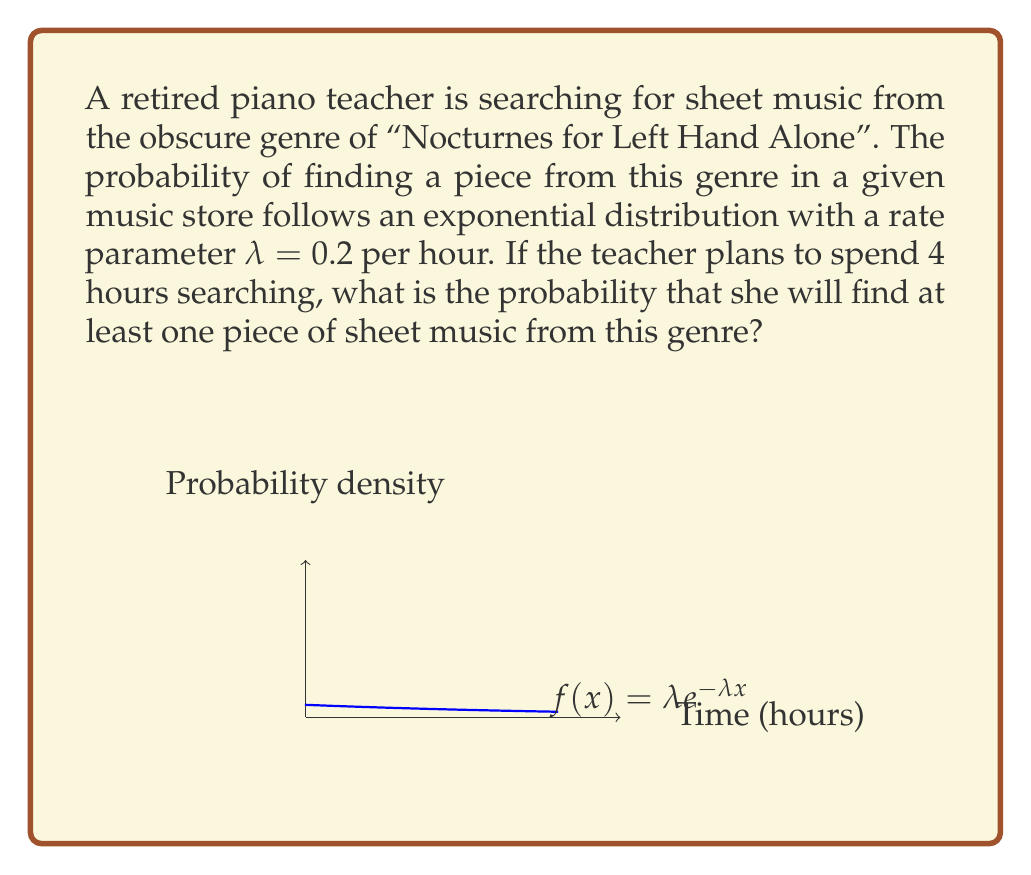Teach me how to tackle this problem. Let's approach this step-by-step:

1) The exponential distribution models the time between events in a Poisson process. In this case, it models the time until finding a piece of sheet music.

2) The cumulative distribution function (CDF) of an exponential distribution is:

   $$F(x) = 1 - e^{-\lambda x}$$

   where $\lambda$ is the rate parameter and $x$ is the time.

3) We want to find the probability of finding at least one piece in 4 hours. This is equivalent to the probability of the time to find a piece being less than or equal to 4 hours.

4) Using the CDF, we can calculate this as:

   $$P(X \leq 4) = F(4) = 1 - e^{-\lambda \cdot 4}$$

5) We're given that $\lambda = 0.2$ per hour. Let's substitute this:

   $$P(X \leq 4) = 1 - e^{-0.2 \cdot 4} = 1 - e^{-0.8}$$

6) Now, let's calculate this:

   $$1 - e^{-0.8} \approx 1 - 0.4493 \approx 0.5507$$

Therefore, the probability of finding at least one piece of sheet music from this genre in 4 hours is approximately 0.5507 or about 55.07%.
Answer: $1 - e^{-0.8} \approx 0.5507$ 